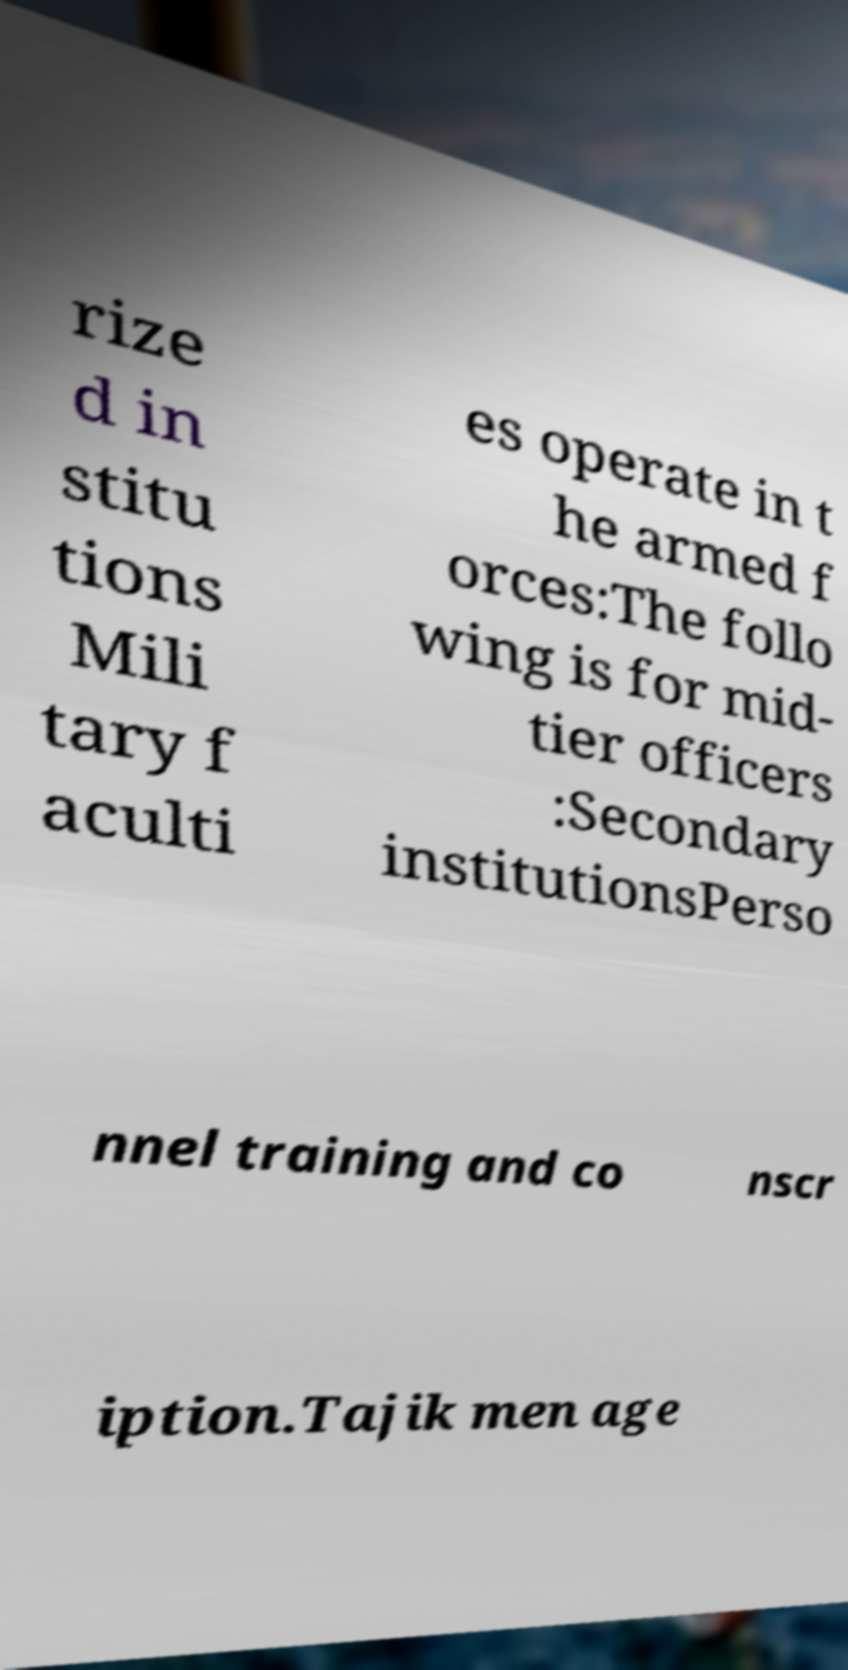Can you accurately transcribe the text from the provided image for me? rize d in stitu tions Mili tary f aculti es operate in t he armed f orces:The follo wing is for mid- tier officers :Secondary institutionsPerso nnel training and co nscr iption.Tajik men age 